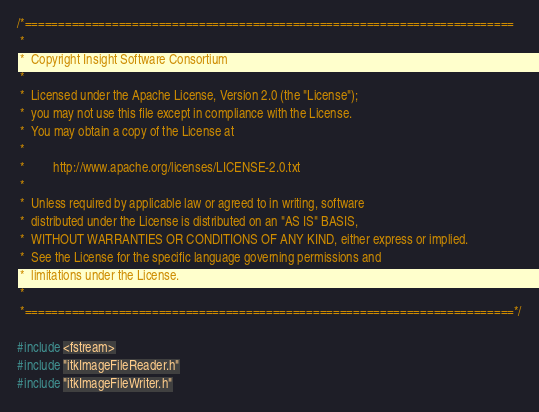<code> <loc_0><loc_0><loc_500><loc_500><_C++_>/*=========================================================================
 *
 *  Copyright Insight Software Consortium
 *
 *  Licensed under the Apache License, Version 2.0 (the "License");
 *  you may not use this file except in compliance with the License.
 *  You may obtain a copy of the License at
 *
 *         http://www.apache.org/licenses/LICENSE-2.0.txt
 *
 *  Unless required by applicable law or agreed to in writing, software
 *  distributed under the License is distributed on an "AS IS" BASIS,
 *  WITHOUT WARRANTIES OR CONDITIONS OF ANY KIND, either express or implied.
 *  See the License for the specific language governing permissions and
 *  limitations under the License.
 *
 *=========================================================================*/

#include <fstream>
#include "itkImageFileReader.h"
#include "itkImageFileWriter.h"</code> 